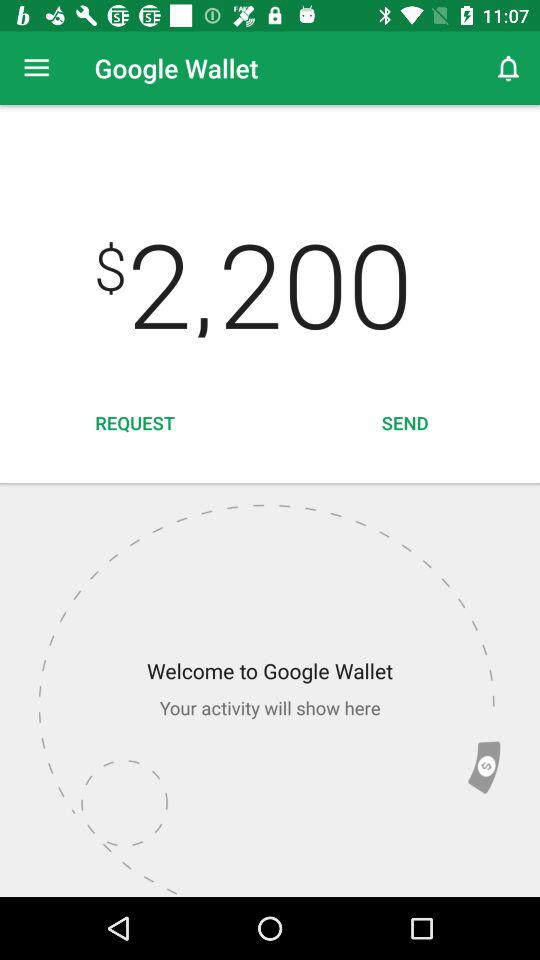How much money is in "Google Wallet"? The money is $2,200. 